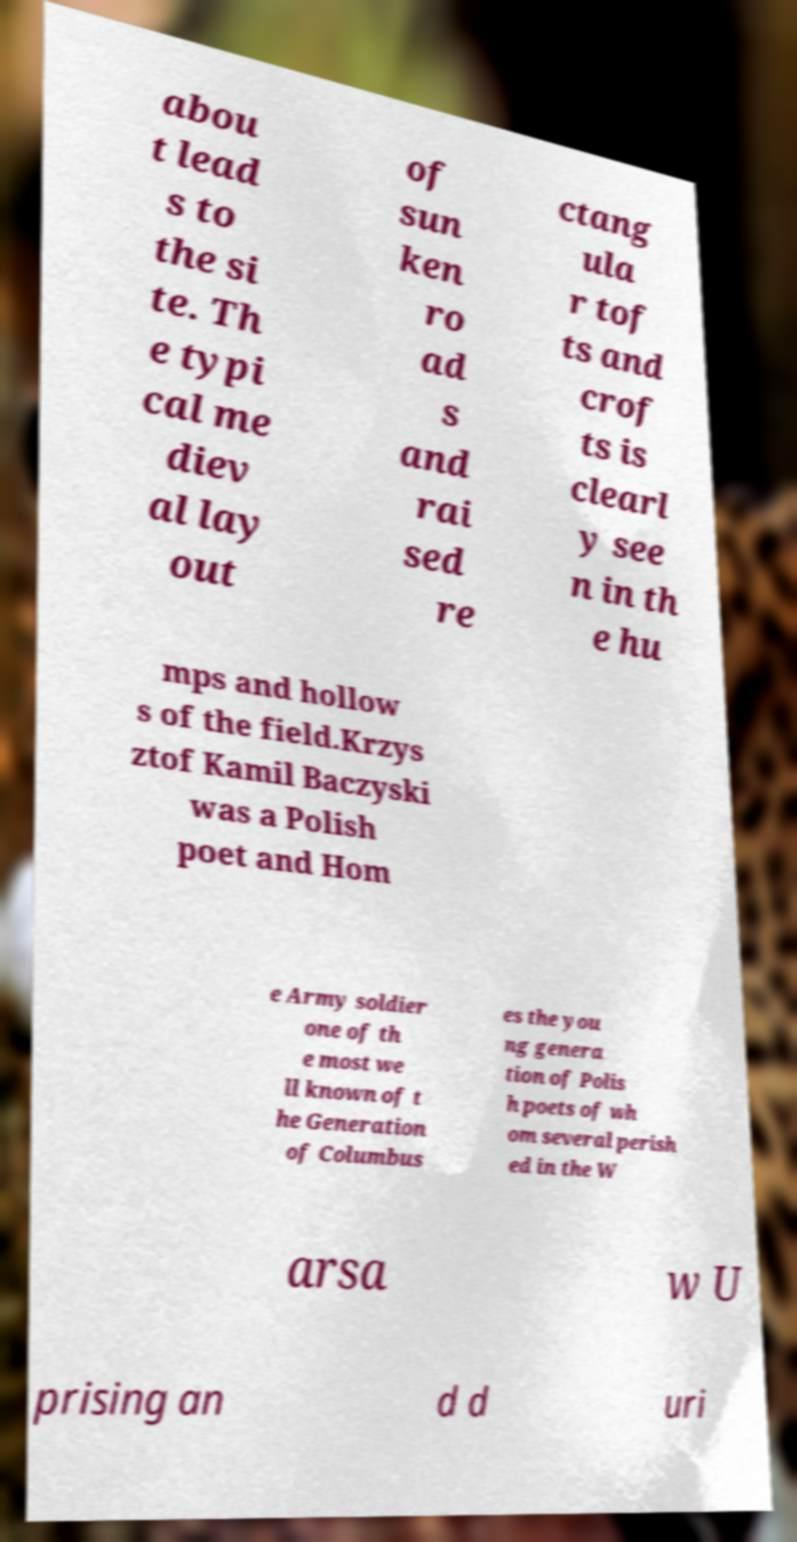Can you read and provide the text displayed in the image?This photo seems to have some interesting text. Can you extract and type it out for me? abou t lead s to the si te. Th e typi cal me diev al lay out of sun ken ro ad s and rai sed re ctang ula r tof ts and crof ts is clearl y see n in th e hu mps and hollow s of the field.Krzys ztof Kamil Baczyski was a Polish poet and Hom e Army soldier one of th e most we ll known of t he Generation of Columbus es the you ng genera tion of Polis h poets of wh om several perish ed in the W arsa w U prising an d d uri 